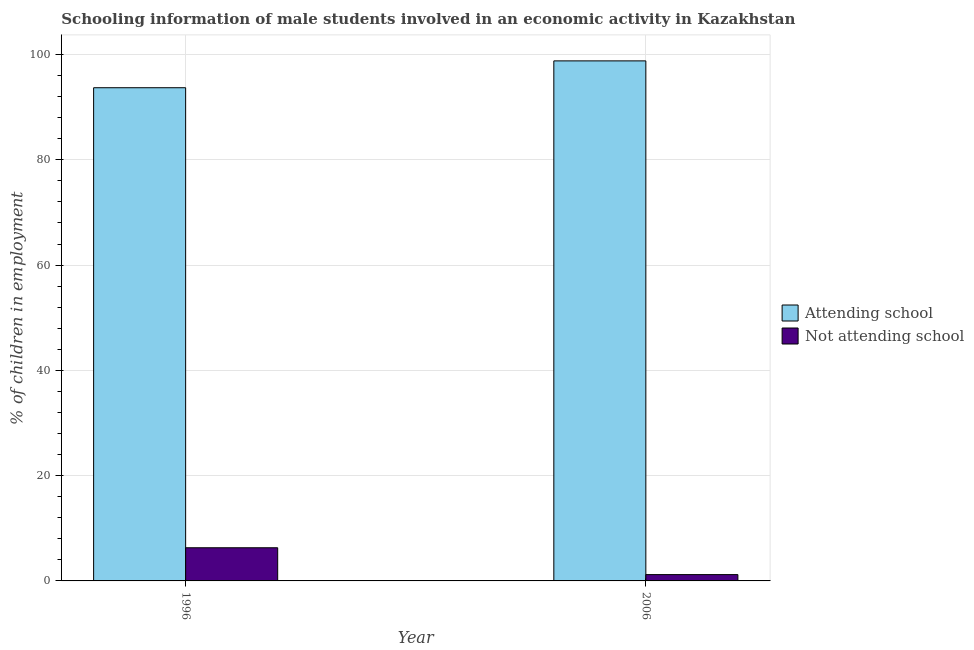How many different coloured bars are there?
Make the answer very short. 2. How many groups of bars are there?
Your answer should be very brief. 2. Are the number of bars on each tick of the X-axis equal?
Your answer should be compact. Yes. What is the label of the 1st group of bars from the left?
Offer a terse response. 1996. In how many cases, is the number of bars for a given year not equal to the number of legend labels?
Offer a terse response. 0. What is the percentage of employed males who are not attending school in 1996?
Your answer should be very brief. 6.3. Across all years, what is the maximum percentage of employed males who are not attending school?
Offer a very short reply. 6.3. Across all years, what is the minimum percentage of employed males who are not attending school?
Your response must be concise. 1.2. In which year was the percentage of employed males who are attending school maximum?
Provide a succinct answer. 2006. In which year was the percentage of employed males who are attending school minimum?
Offer a very short reply. 1996. What is the total percentage of employed males who are not attending school in the graph?
Ensure brevity in your answer.  7.5. What is the difference between the percentage of employed males who are attending school in 2006 and the percentage of employed males who are not attending school in 1996?
Provide a succinct answer. 5.1. What is the average percentage of employed males who are attending school per year?
Offer a very short reply. 96.25. In the year 1996, what is the difference between the percentage of employed males who are not attending school and percentage of employed males who are attending school?
Ensure brevity in your answer.  0. In how many years, is the percentage of employed males who are attending school greater than 88 %?
Provide a short and direct response. 2. What is the ratio of the percentage of employed males who are attending school in 1996 to that in 2006?
Give a very brief answer. 0.95. Is the percentage of employed males who are not attending school in 1996 less than that in 2006?
Ensure brevity in your answer.  No. What does the 1st bar from the left in 1996 represents?
Your answer should be compact. Attending school. What does the 2nd bar from the right in 1996 represents?
Give a very brief answer. Attending school. How many bars are there?
Your answer should be compact. 4. How many years are there in the graph?
Provide a short and direct response. 2. What is the difference between two consecutive major ticks on the Y-axis?
Ensure brevity in your answer.  20. Does the graph contain grids?
Provide a short and direct response. Yes. How many legend labels are there?
Your answer should be very brief. 2. What is the title of the graph?
Provide a short and direct response. Schooling information of male students involved in an economic activity in Kazakhstan. What is the label or title of the Y-axis?
Make the answer very short. % of children in employment. What is the % of children in employment in Attending school in 1996?
Offer a very short reply. 93.7. What is the % of children in employment of Not attending school in 1996?
Your response must be concise. 6.3. What is the % of children in employment of Attending school in 2006?
Keep it short and to the point. 98.8. What is the % of children in employment in Not attending school in 2006?
Make the answer very short. 1.2. Across all years, what is the maximum % of children in employment in Attending school?
Make the answer very short. 98.8. Across all years, what is the maximum % of children in employment in Not attending school?
Provide a short and direct response. 6.3. Across all years, what is the minimum % of children in employment of Attending school?
Keep it short and to the point. 93.7. Across all years, what is the minimum % of children in employment in Not attending school?
Offer a terse response. 1.2. What is the total % of children in employment of Attending school in the graph?
Your response must be concise. 192.5. What is the total % of children in employment in Not attending school in the graph?
Provide a short and direct response. 7.5. What is the difference between the % of children in employment in Attending school in 1996 and that in 2006?
Your response must be concise. -5.1. What is the difference between the % of children in employment of Attending school in 1996 and the % of children in employment of Not attending school in 2006?
Make the answer very short. 92.5. What is the average % of children in employment of Attending school per year?
Provide a succinct answer. 96.25. What is the average % of children in employment in Not attending school per year?
Keep it short and to the point. 3.75. In the year 1996, what is the difference between the % of children in employment in Attending school and % of children in employment in Not attending school?
Keep it short and to the point. 87.4. In the year 2006, what is the difference between the % of children in employment in Attending school and % of children in employment in Not attending school?
Your answer should be compact. 97.6. What is the ratio of the % of children in employment in Attending school in 1996 to that in 2006?
Keep it short and to the point. 0.95. What is the ratio of the % of children in employment in Not attending school in 1996 to that in 2006?
Your answer should be compact. 5.25. What is the difference between the highest and the second highest % of children in employment in Attending school?
Offer a terse response. 5.1. What is the difference between the highest and the lowest % of children in employment of Attending school?
Your answer should be very brief. 5.1. 